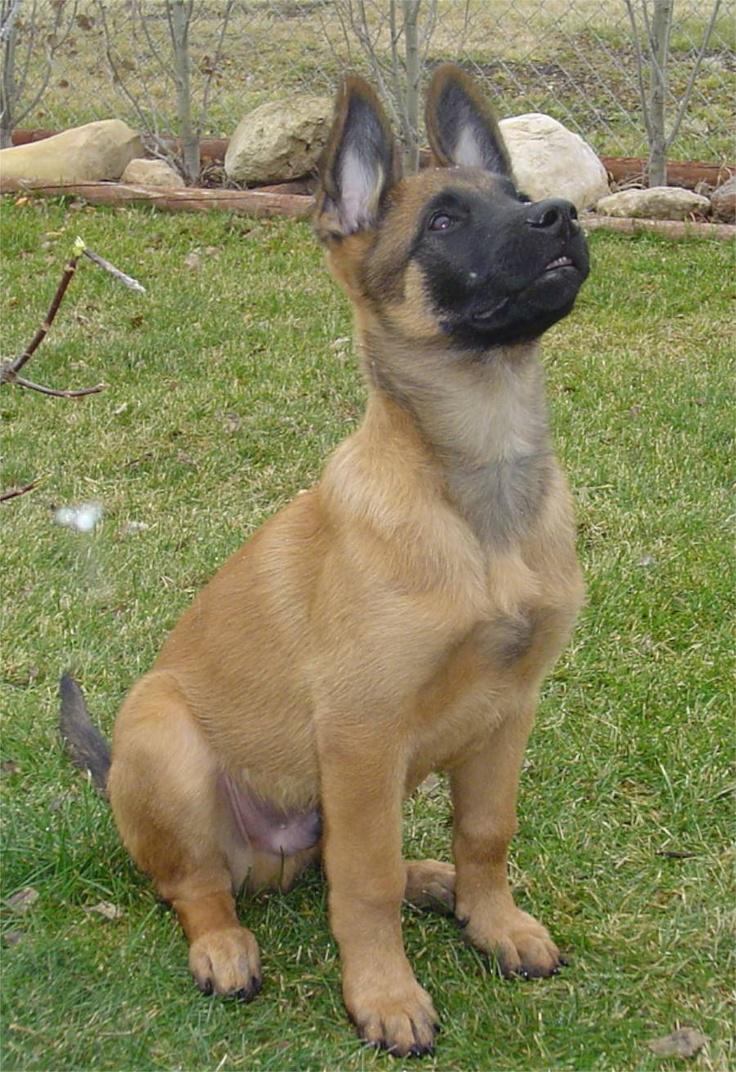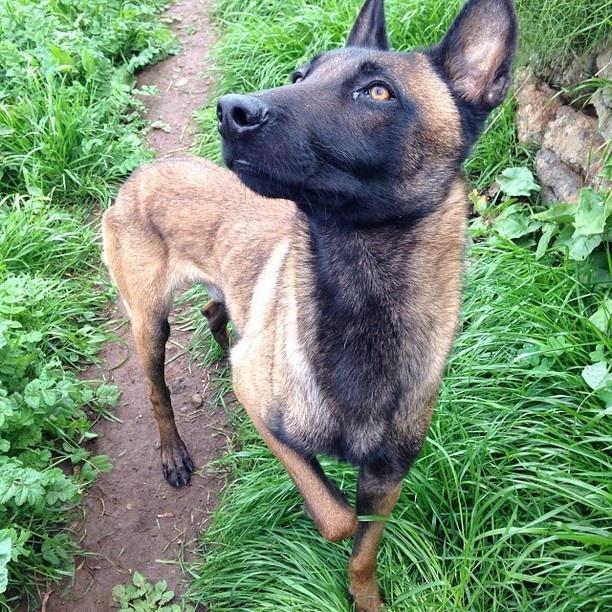The first image is the image on the left, the second image is the image on the right. Given the left and right images, does the statement "There is at least one dog sitting down" hold true? Answer yes or no. Yes. The first image is the image on the left, the second image is the image on the right. Considering the images on both sides, is "The dog in the image on the left is sitting." valid? Answer yes or no. Yes. 